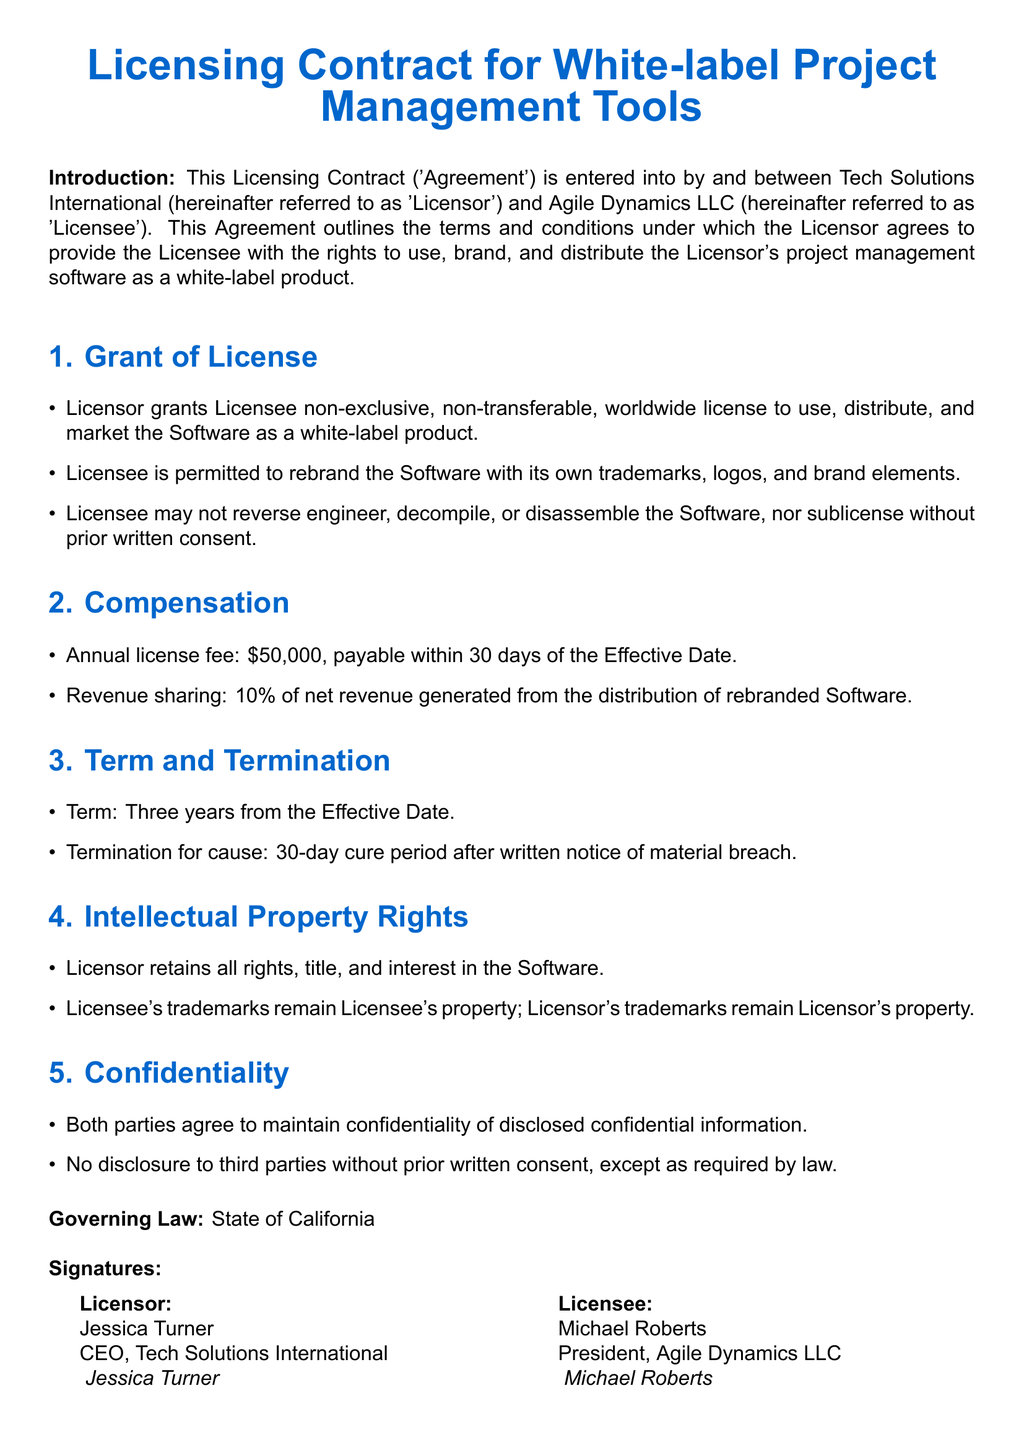What is the name of the Licensor? The Licensor is Tech Solutions International, mentioned in the introduction of the document.
Answer: Tech Solutions International Who should the license fee be paid to? The license fee should be paid to the Licensor, as stated in the Compensation section.
Answer: Licensor What is the annual license fee? The annual license fee is specified in the Compensation section of the document.
Answer: $50,000 What percentage of net revenue is shared? The Revenue sharing percentage is clearly stated in the Compensation section of the document.
Answer: 10% What is the term duration of the contract? The duration of the contract is explicitly mentioned in the Term and Termination section.
Answer: Three years Who retains the rights to the trademarks? The section on Intellectual Property Rights specifies ownership of trademarks.
Answer: Licensor What is the governing law for this agreement? The document explicitly states the governing law in the designated section.
Answer: State of California What happens after a material breach is noted? The Term and Termination section outlines actions following a material breach.
Answer: 30-day cure period Who signed as the Licensee? The Licensee's name is found in the Signatures section of the document.
Answer: Michael Roberts 